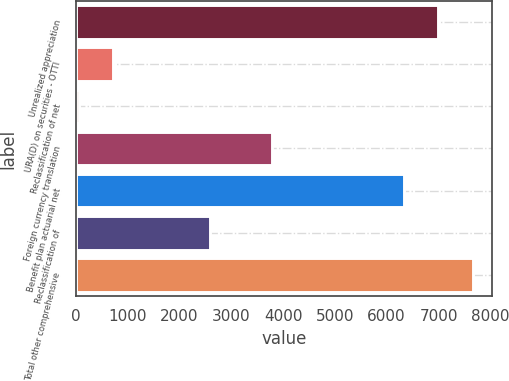<chart> <loc_0><loc_0><loc_500><loc_500><bar_chart><fcel>Unrealized appreciation<fcel>URA(D) on securities - OTTI<fcel>Reclassification of net<fcel>Foreign currency translation<fcel>Benefit plan actuarial net<fcel>Reclassification of<fcel>Total other comprehensive<nl><fcel>6997.1<fcel>729.1<fcel>70<fcel>3786<fcel>6338<fcel>2582<fcel>7656.2<nl></chart> 